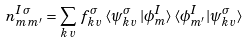<formula> <loc_0><loc_0><loc_500><loc_500>n ^ { I \, \sigma } _ { m \, m ^ { \prime } } = \sum _ { { k } \, v } \, f ^ { \sigma } _ { { k } \, v } \, \langle \psi _ { { k } \, v } ^ { \sigma } \, | \phi _ { m } ^ { I } \rangle \, \langle \phi _ { m ^ { \prime } } ^ { I } | \psi _ { { k } \, v } ^ { \sigma } \rangle</formula> 